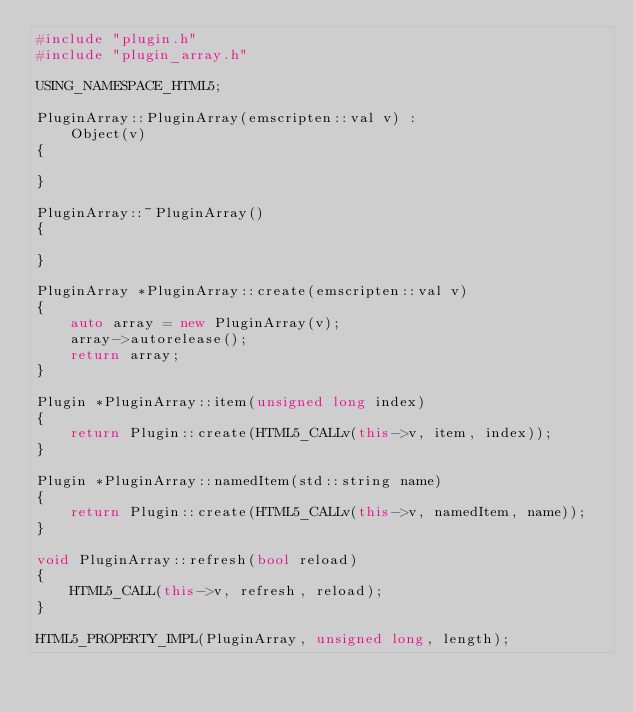<code> <loc_0><loc_0><loc_500><loc_500><_C++_>#include "plugin.h"
#include "plugin_array.h"

USING_NAMESPACE_HTML5;

PluginArray::PluginArray(emscripten::val v) :
    Object(v)
{

}

PluginArray::~PluginArray()
{

}

PluginArray *PluginArray::create(emscripten::val v)
{
    auto array = new PluginArray(v);
    array->autorelease();
    return array;
}

Plugin *PluginArray::item(unsigned long index)
{
    return Plugin::create(HTML5_CALLv(this->v, item, index));
}

Plugin *PluginArray::namedItem(std::string name)
{
    return Plugin::create(HTML5_CALLv(this->v, namedItem, name));
}

void PluginArray::refresh(bool reload)
{
    HTML5_CALL(this->v, refresh, reload);
}

HTML5_PROPERTY_IMPL(PluginArray, unsigned long, length);
</code> 